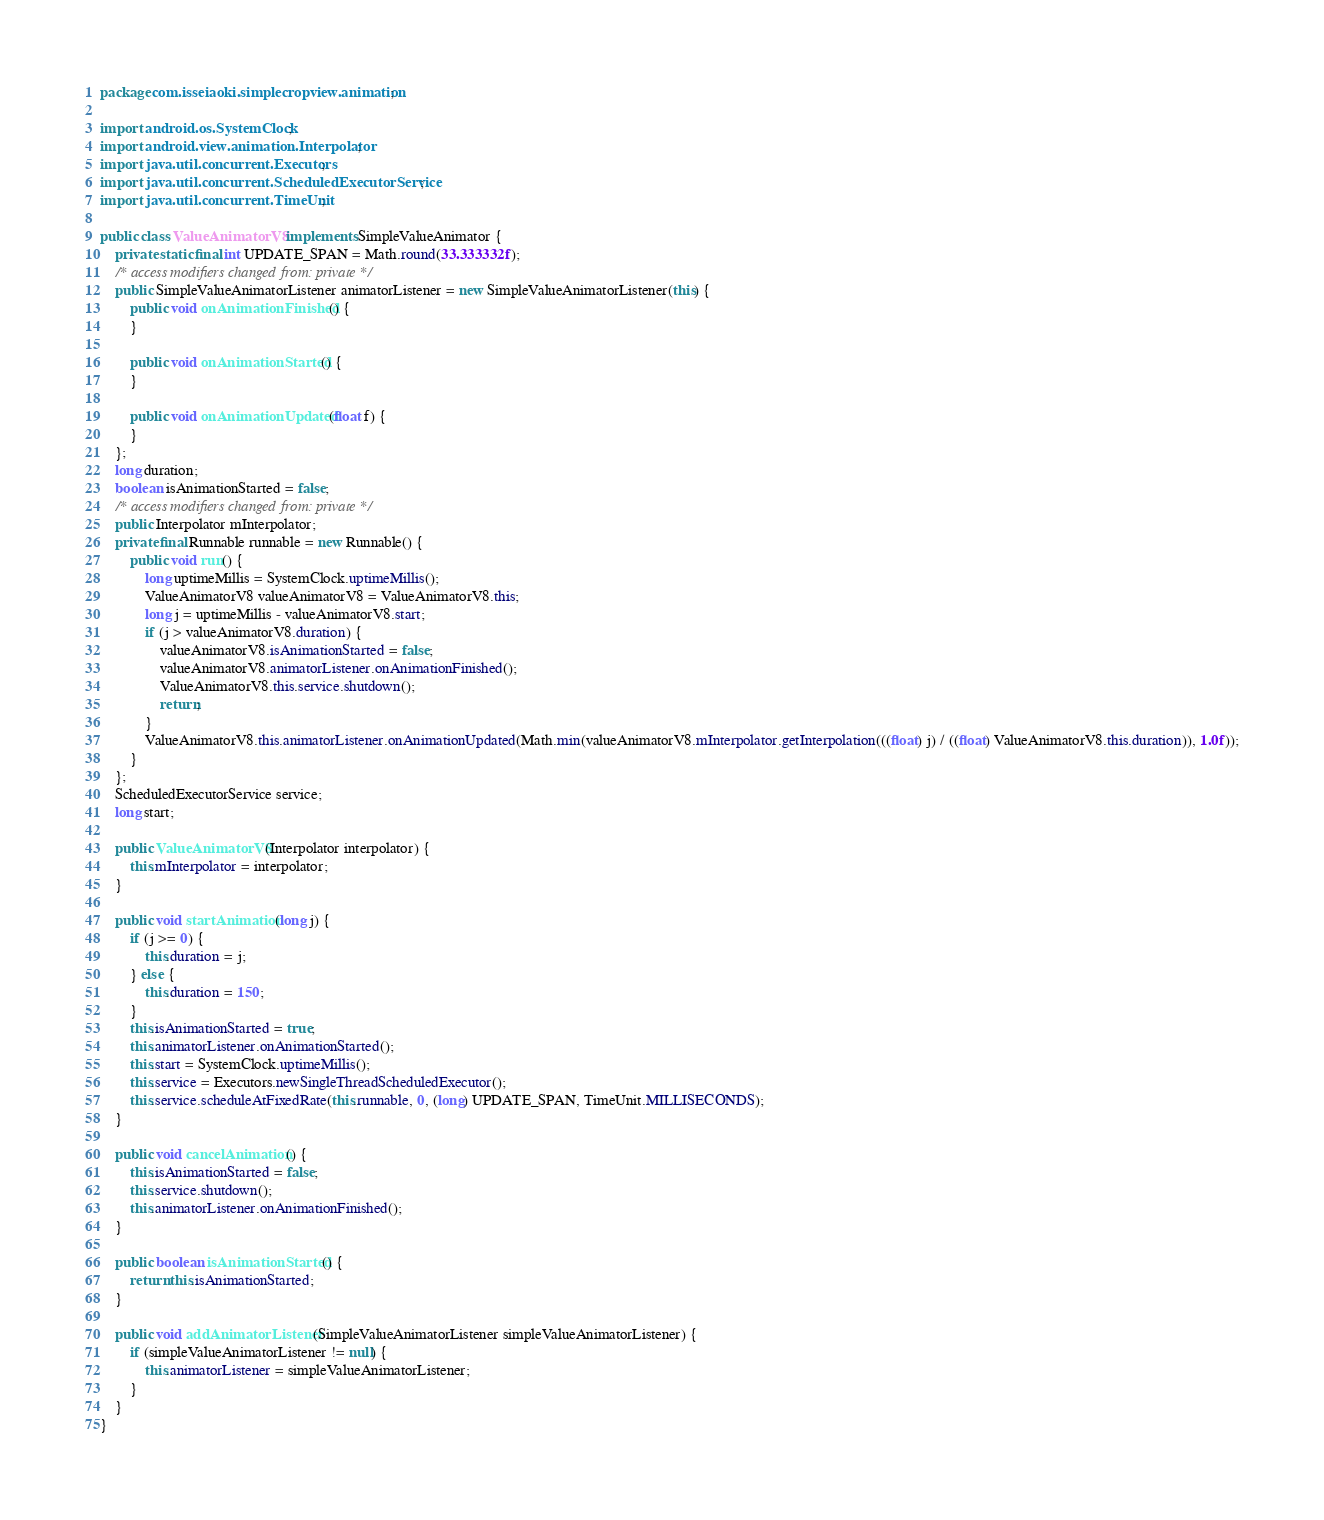<code> <loc_0><loc_0><loc_500><loc_500><_Java_>package com.isseiaoki.simplecropview.animation;

import android.os.SystemClock;
import android.view.animation.Interpolator;
import java.util.concurrent.Executors;
import java.util.concurrent.ScheduledExecutorService;
import java.util.concurrent.TimeUnit;

public class ValueAnimatorV8 implements SimpleValueAnimator {
    private static final int UPDATE_SPAN = Math.round(33.333332f);
    /* access modifiers changed from: private */
    public SimpleValueAnimatorListener animatorListener = new SimpleValueAnimatorListener(this) {
        public void onAnimationFinished() {
        }

        public void onAnimationStarted() {
        }

        public void onAnimationUpdated(float f) {
        }
    };
    long duration;
    boolean isAnimationStarted = false;
    /* access modifiers changed from: private */
    public Interpolator mInterpolator;
    private final Runnable runnable = new Runnable() {
        public void run() {
            long uptimeMillis = SystemClock.uptimeMillis();
            ValueAnimatorV8 valueAnimatorV8 = ValueAnimatorV8.this;
            long j = uptimeMillis - valueAnimatorV8.start;
            if (j > valueAnimatorV8.duration) {
                valueAnimatorV8.isAnimationStarted = false;
                valueAnimatorV8.animatorListener.onAnimationFinished();
                ValueAnimatorV8.this.service.shutdown();
                return;
            }
            ValueAnimatorV8.this.animatorListener.onAnimationUpdated(Math.min(valueAnimatorV8.mInterpolator.getInterpolation(((float) j) / ((float) ValueAnimatorV8.this.duration)), 1.0f));
        }
    };
    ScheduledExecutorService service;
    long start;

    public ValueAnimatorV8(Interpolator interpolator) {
        this.mInterpolator = interpolator;
    }

    public void startAnimation(long j) {
        if (j >= 0) {
            this.duration = j;
        } else {
            this.duration = 150;
        }
        this.isAnimationStarted = true;
        this.animatorListener.onAnimationStarted();
        this.start = SystemClock.uptimeMillis();
        this.service = Executors.newSingleThreadScheduledExecutor();
        this.service.scheduleAtFixedRate(this.runnable, 0, (long) UPDATE_SPAN, TimeUnit.MILLISECONDS);
    }

    public void cancelAnimation() {
        this.isAnimationStarted = false;
        this.service.shutdown();
        this.animatorListener.onAnimationFinished();
    }

    public boolean isAnimationStarted() {
        return this.isAnimationStarted;
    }

    public void addAnimatorListener(SimpleValueAnimatorListener simpleValueAnimatorListener) {
        if (simpleValueAnimatorListener != null) {
            this.animatorListener = simpleValueAnimatorListener;
        }
    }
}
</code> 